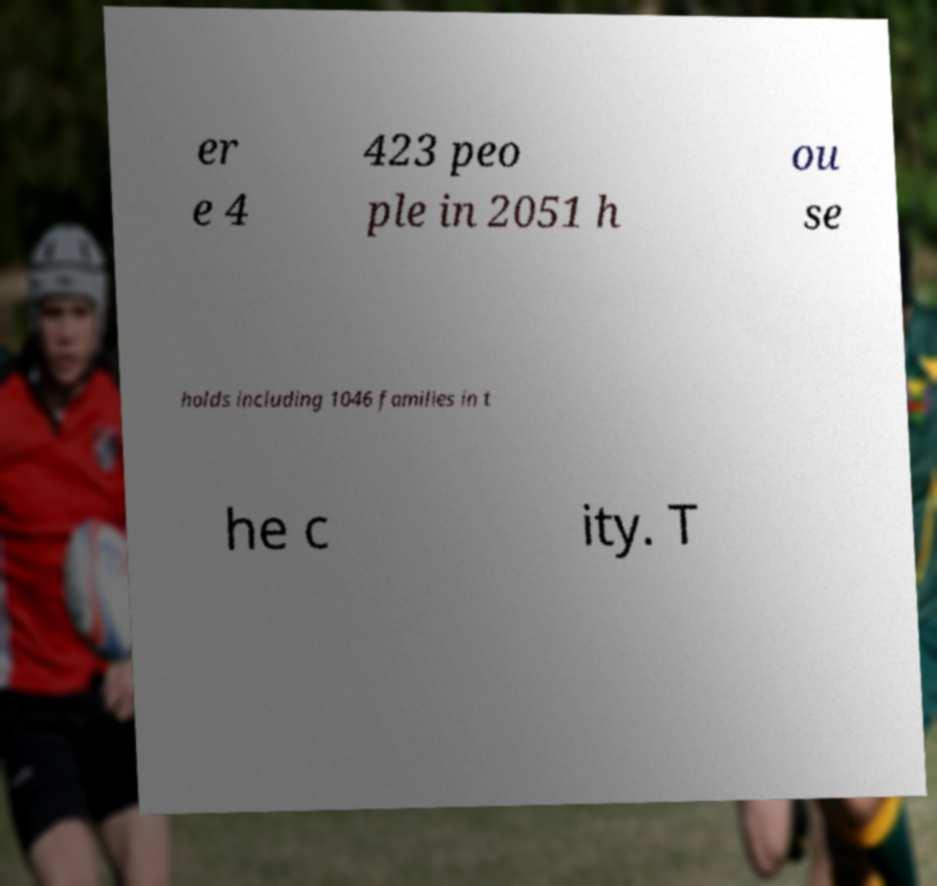For documentation purposes, I need the text within this image transcribed. Could you provide that? er e 4 423 peo ple in 2051 h ou se holds including 1046 families in t he c ity. T 